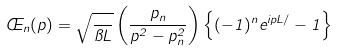<formula> <loc_0><loc_0><loc_500><loc_500>\phi _ { n } ( p ) = \sqrt { \frac { } { \pi L } } \left ( \frac { p _ { n } } { p ^ { 2 } - p _ { n } ^ { 2 } } \right ) \left \{ ( - 1 ) ^ { n } e ^ { i p L / } - 1 \right \}</formula> 